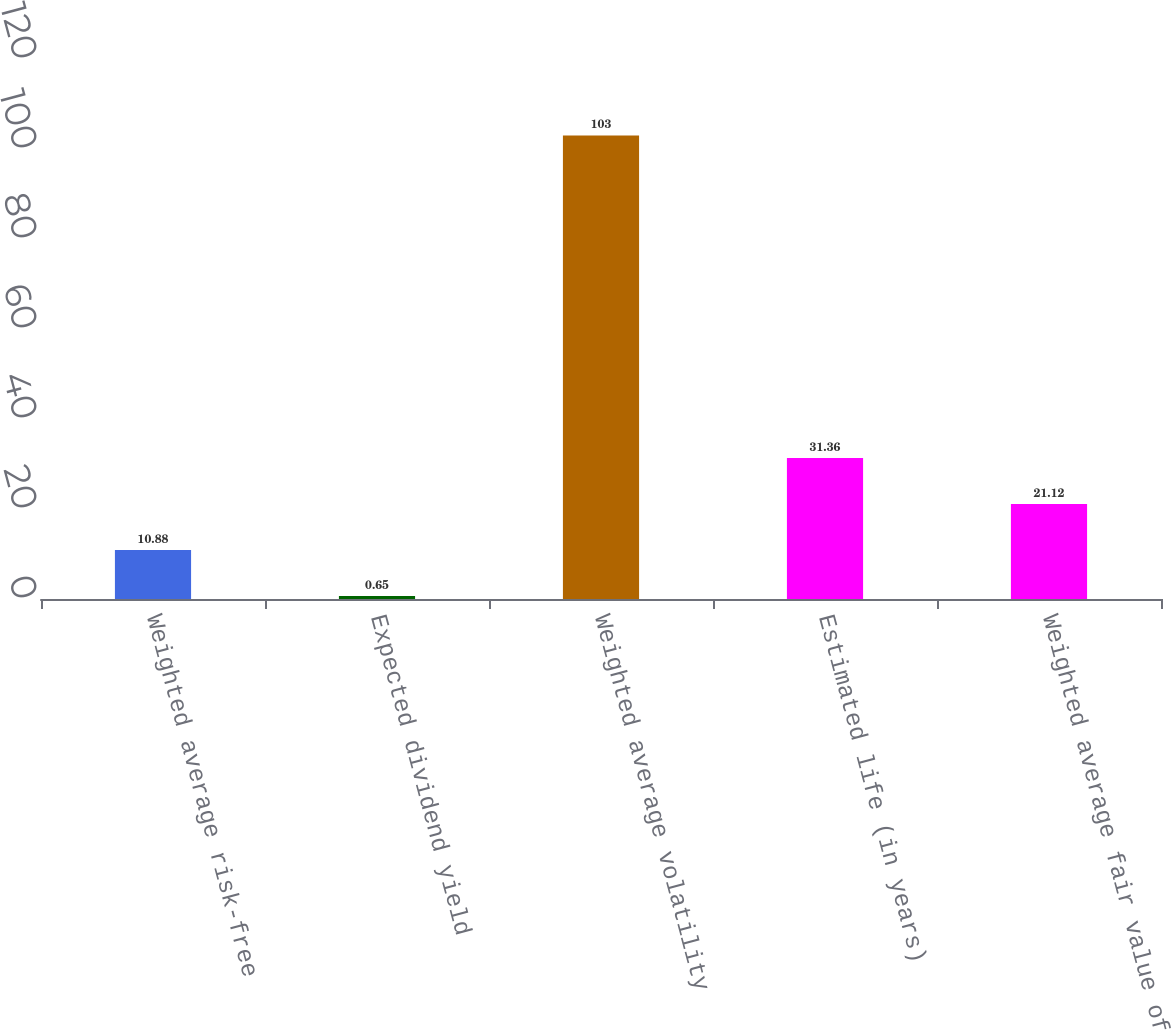Convert chart to OTSL. <chart><loc_0><loc_0><loc_500><loc_500><bar_chart><fcel>Weighted average risk-free<fcel>Expected dividend yield<fcel>Weighted average volatility<fcel>Estimated life (in years)<fcel>Weighted average fair value of<nl><fcel>10.88<fcel>0.65<fcel>103<fcel>31.36<fcel>21.12<nl></chart> 